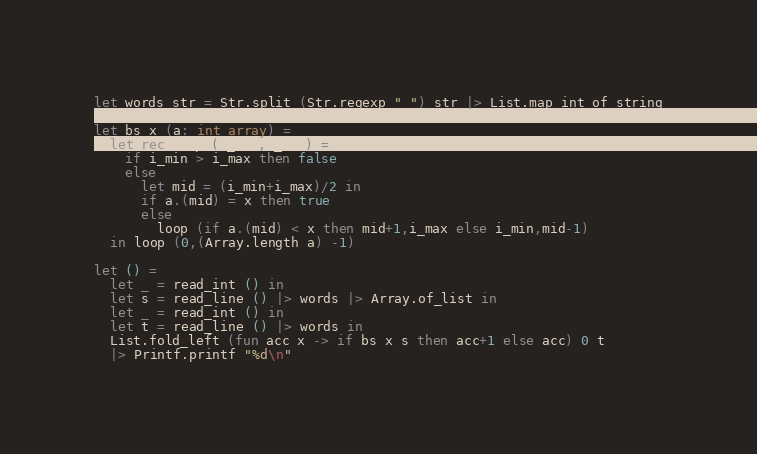Convert code to text. <code><loc_0><loc_0><loc_500><loc_500><_OCaml_>let words str = Str.split (Str.regexp " ") str |> List.map int_of_string

let bs x (a: int array) =
  let rec loop (i_min,i_max) =
    if i_min > i_max then false
    else
      let mid = (i_min+i_max)/2 in
      if a.(mid) = x then true
      else
        loop (if a.(mid) < x then mid+1,i_max else i_min,mid-1)
  in loop (0,(Array.length a) -1)

let () =
  let _ = read_int () in
  let s = read_line () |> words |> Array.of_list in
  let _ = read_int () in
  let t = read_line () |> words in
  List.fold_left (fun acc x -> if bs x s then acc+1 else acc) 0 t
  |> Printf.printf "%d\n"</code> 